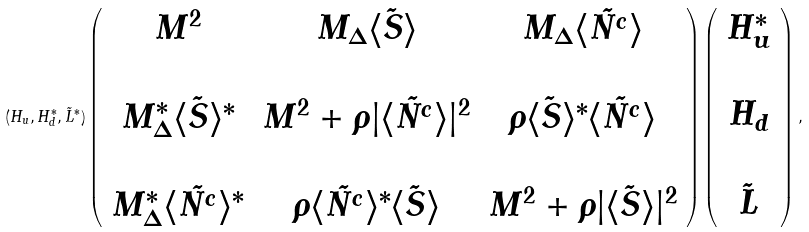Convert formula to latex. <formula><loc_0><loc_0><loc_500><loc_500>( H _ { u } , H _ { d } ^ { * } , \tilde { L } ^ { * } ) \left ( \begin{array} { c c c } M ^ { 2 } & M _ { \Delta } \langle \tilde { S } \rangle & M _ { \Delta } \langle \tilde { N ^ { c } } \rangle \\ & & \\ M _ { \Delta } ^ { * } \langle \tilde { S } \rangle ^ { * } & M ^ { 2 } + \rho | \langle \tilde { N ^ { c } } \rangle | ^ { 2 } & \rho \langle \tilde { S } \rangle ^ { * } \langle \tilde { N ^ { c } } \rangle \\ & & \\ M _ { \Delta } ^ { * } \langle \tilde { N ^ { c } } \rangle ^ { * } & \rho \langle \tilde { N ^ { c } } \rangle ^ { * } \langle \tilde { S } \rangle & M ^ { 2 } + \rho | \langle \tilde { S } \rangle | ^ { 2 } \end{array} \right ) \left ( \begin{array} { c } H _ { u } ^ { * } \\ \\ H _ { d } \\ \\ \tilde { L } \end{array} \right ) ,</formula> 